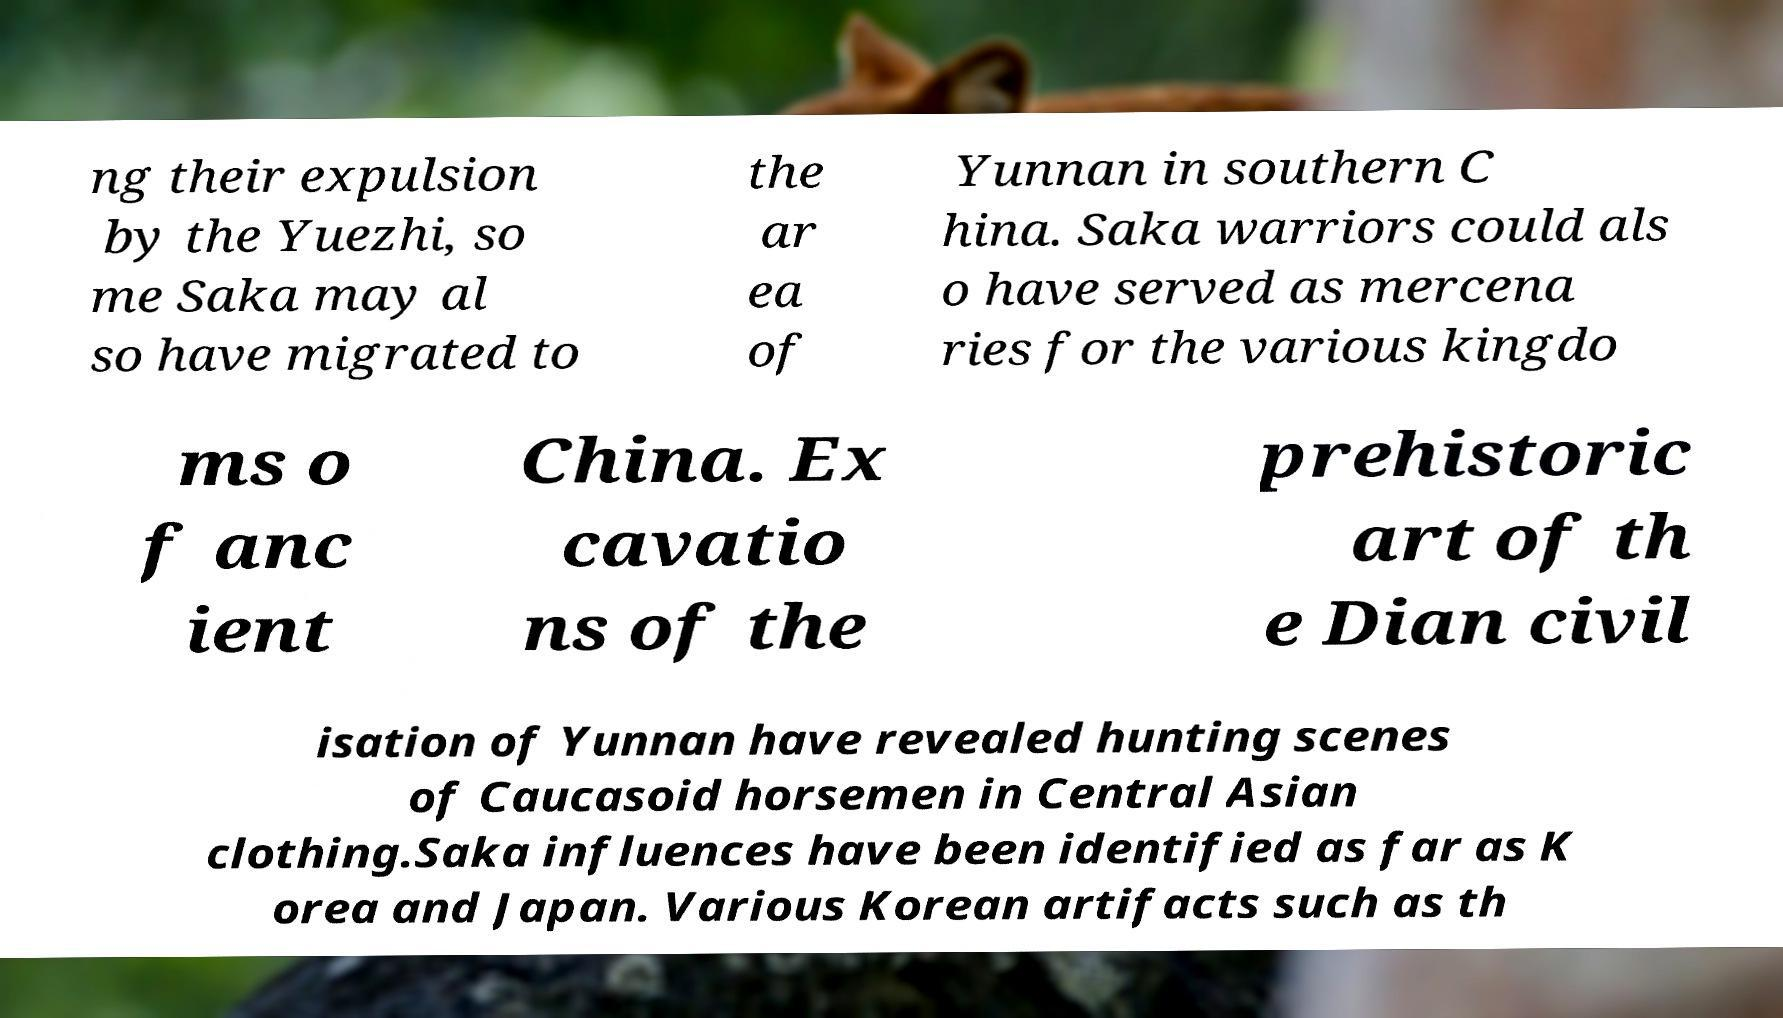Can you accurately transcribe the text from the provided image for me? ng their expulsion by the Yuezhi, so me Saka may al so have migrated to the ar ea of Yunnan in southern C hina. Saka warriors could als o have served as mercena ries for the various kingdo ms o f anc ient China. Ex cavatio ns of the prehistoric art of th e Dian civil isation of Yunnan have revealed hunting scenes of Caucasoid horsemen in Central Asian clothing.Saka influences have been identified as far as K orea and Japan. Various Korean artifacts such as th 